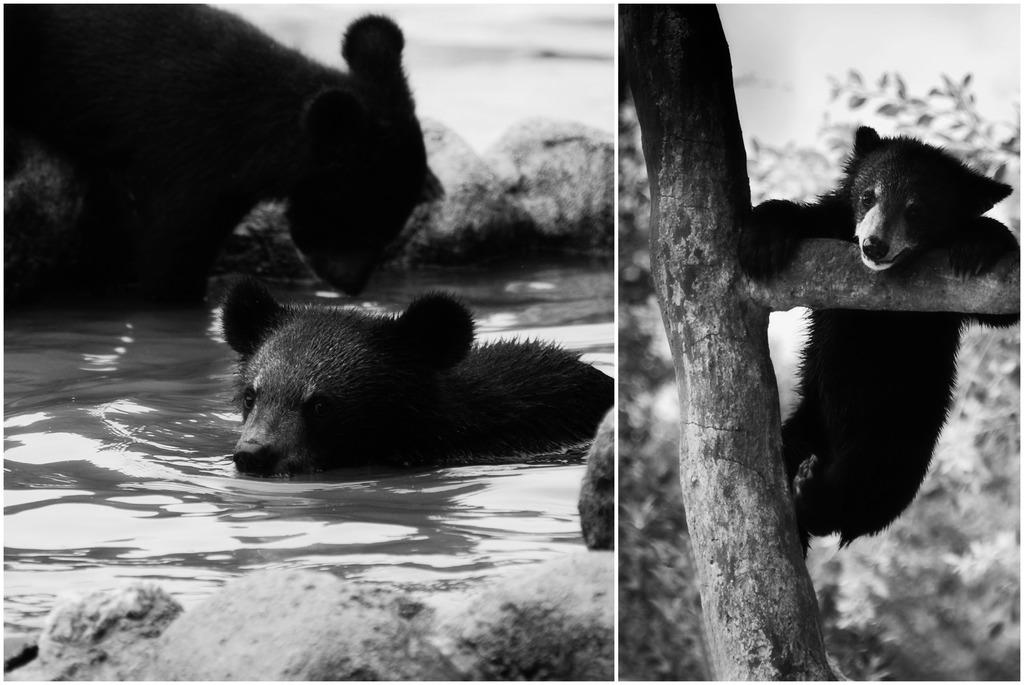What type of animal is in the image? There is an American black bear in the image. Where is the bear located in the image? The bear is in the water and hanging on a branch of a tree. What other natural elements can be seen in the image? There are rocks, water, and trees visible in the image. What type of jam is the bear spreading on the basket in the image? There is no jam or basket present in the image; it features an American black bear in the water and hanging on a tree branch. 